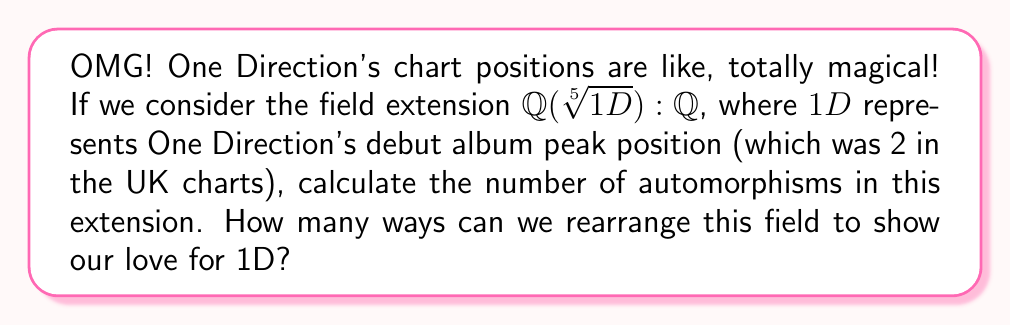What is the answer to this math problem? Let's break this down step by step, just like analyzing every detail of a Harry Styles performance!

1) First, we need to identify the degree of the extension $\mathbb{Q}(\sqrt[5]{1D}):\mathbb{Q}$. 
   Since $1D = 2$ (their UK chart position), we're actually looking at $\mathbb{Q}(\sqrt[5]{2}):\mathbb{Q}$.

2) The polynomial $x^5 - 2$ is irreducible over $\mathbb{Q}$ by Eisenstein's criterion with prime $p=2$.

3) Therefore, the degree of the extension is 5, i.e., $[\mathbb{Q}(\sqrt[5]{2}):\mathbb{Q}] = 5$.

4) Now, we need to determine if this extension is normal and separable:
   - It's not normal because not all roots of $x^5 - 2$ are in $\mathbb{Q}(\sqrt[5]{2})$.
   - It is separable because the characteristic of $\mathbb{Q}$ is 0.

5) For a non-normal separable extension, the number of automorphisms is always 1.

6) This means there's only one way to rearrange this field extension, just like there's only one One Direction in our hearts!
Answer: 1 